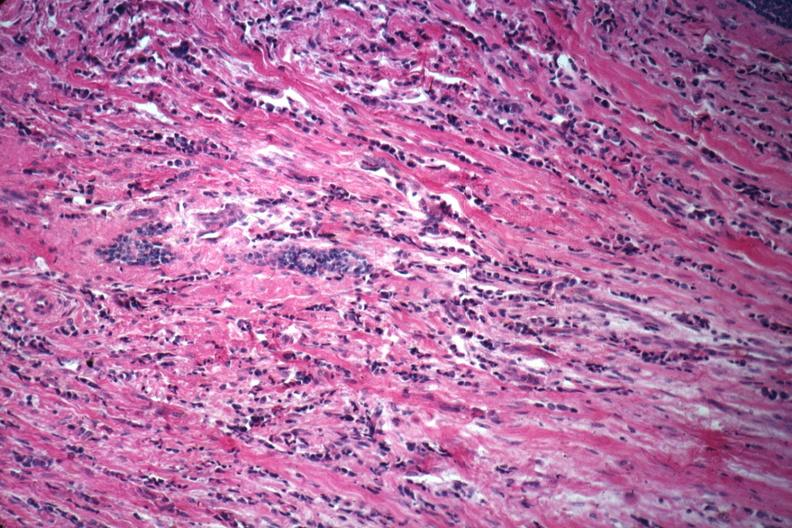does this image show good example of poorly differentiated infiltrating ductal carcinoma?
Answer the question using a single word or phrase. Yes 